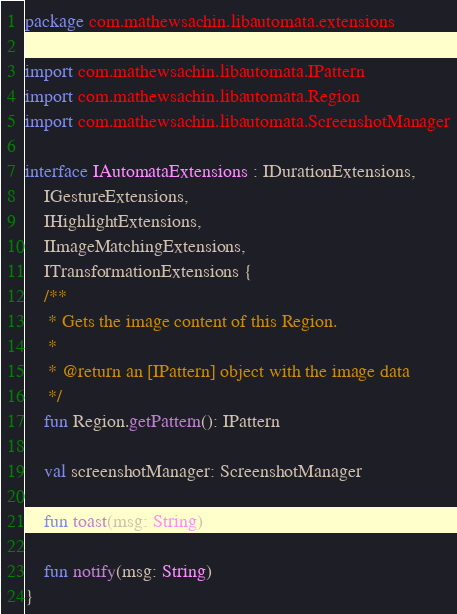Convert code to text. <code><loc_0><loc_0><loc_500><loc_500><_Kotlin_>package com.mathewsachin.libautomata.extensions

import com.mathewsachin.libautomata.IPattern
import com.mathewsachin.libautomata.Region
import com.mathewsachin.libautomata.ScreenshotManager

interface IAutomataExtensions : IDurationExtensions,
    IGestureExtensions,
    IHighlightExtensions,
    IImageMatchingExtensions,
    ITransformationExtensions {
    /**
     * Gets the image content of this Region.
     *
     * @return an [IPattern] object with the image data
     */
    fun Region.getPattern(): IPattern

    val screenshotManager: ScreenshotManager

    fun toast(msg: String)

    fun notify(msg: String)
}</code> 